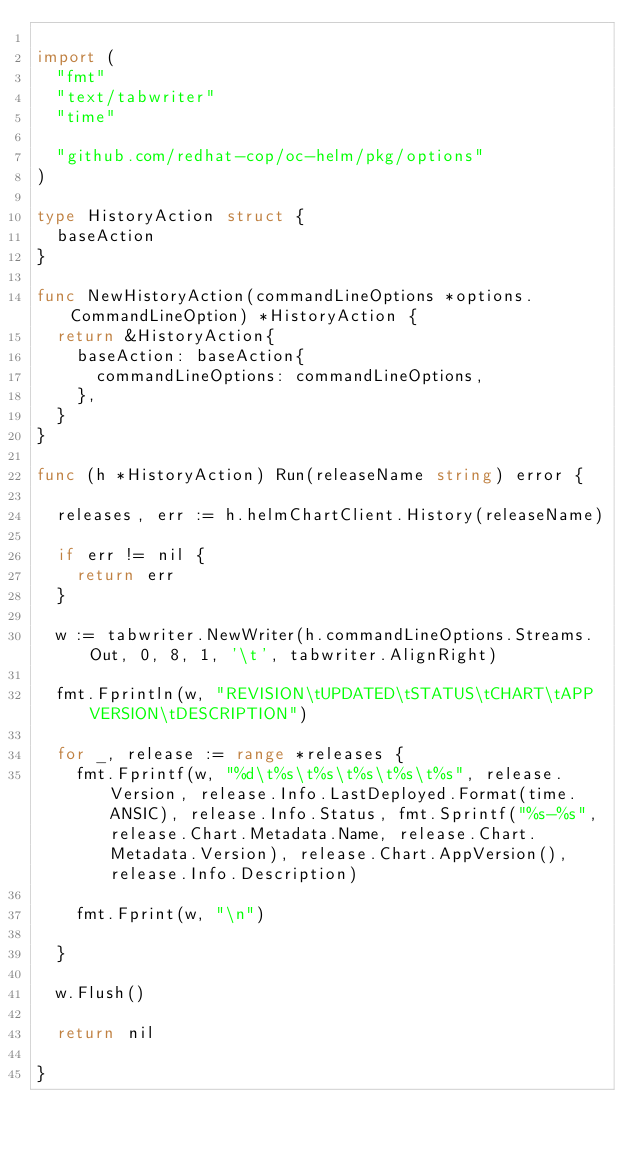Convert code to text. <code><loc_0><loc_0><loc_500><loc_500><_Go_>
import (
	"fmt"
	"text/tabwriter"
	"time"

	"github.com/redhat-cop/oc-helm/pkg/options"
)

type HistoryAction struct {
	baseAction
}

func NewHistoryAction(commandLineOptions *options.CommandLineOption) *HistoryAction {
	return &HistoryAction{
		baseAction: baseAction{
			commandLineOptions: commandLineOptions,
		},
	}
}

func (h *HistoryAction) Run(releaseName string) error {

	releases, err := h.helmChartClient.History(releaseName)

	if err != nil {
		return err
	}

	w := tabwriter.NewWriter(h.commandLineOptions.Streams.Out, 0, 8, 1, '\t', tabwriter.AlignRight)

	fmt.Fprintln(w, "REVISION\tUPDATED\tSTATUS\tCHART\tAPP VERSION\tDESCRIPTION")

	for _, release := range *releases {
		fmt.Fprintf(w, "%d\t%s\t%s\t%s\t%s\t%s", release.Version, release.Info.LastDeployed.Format(time.ANSIC), release.Info.Status, fmt.Sprintf("%s-%s", release.Chart.Metadata.Name, release.Chart.Metadata.Version), release.Chart.AppVersion(), release.Info.Description)

		fmt.Fprint(w, "\n")

	}

	w.Flush()

	return nil

}
</code> 